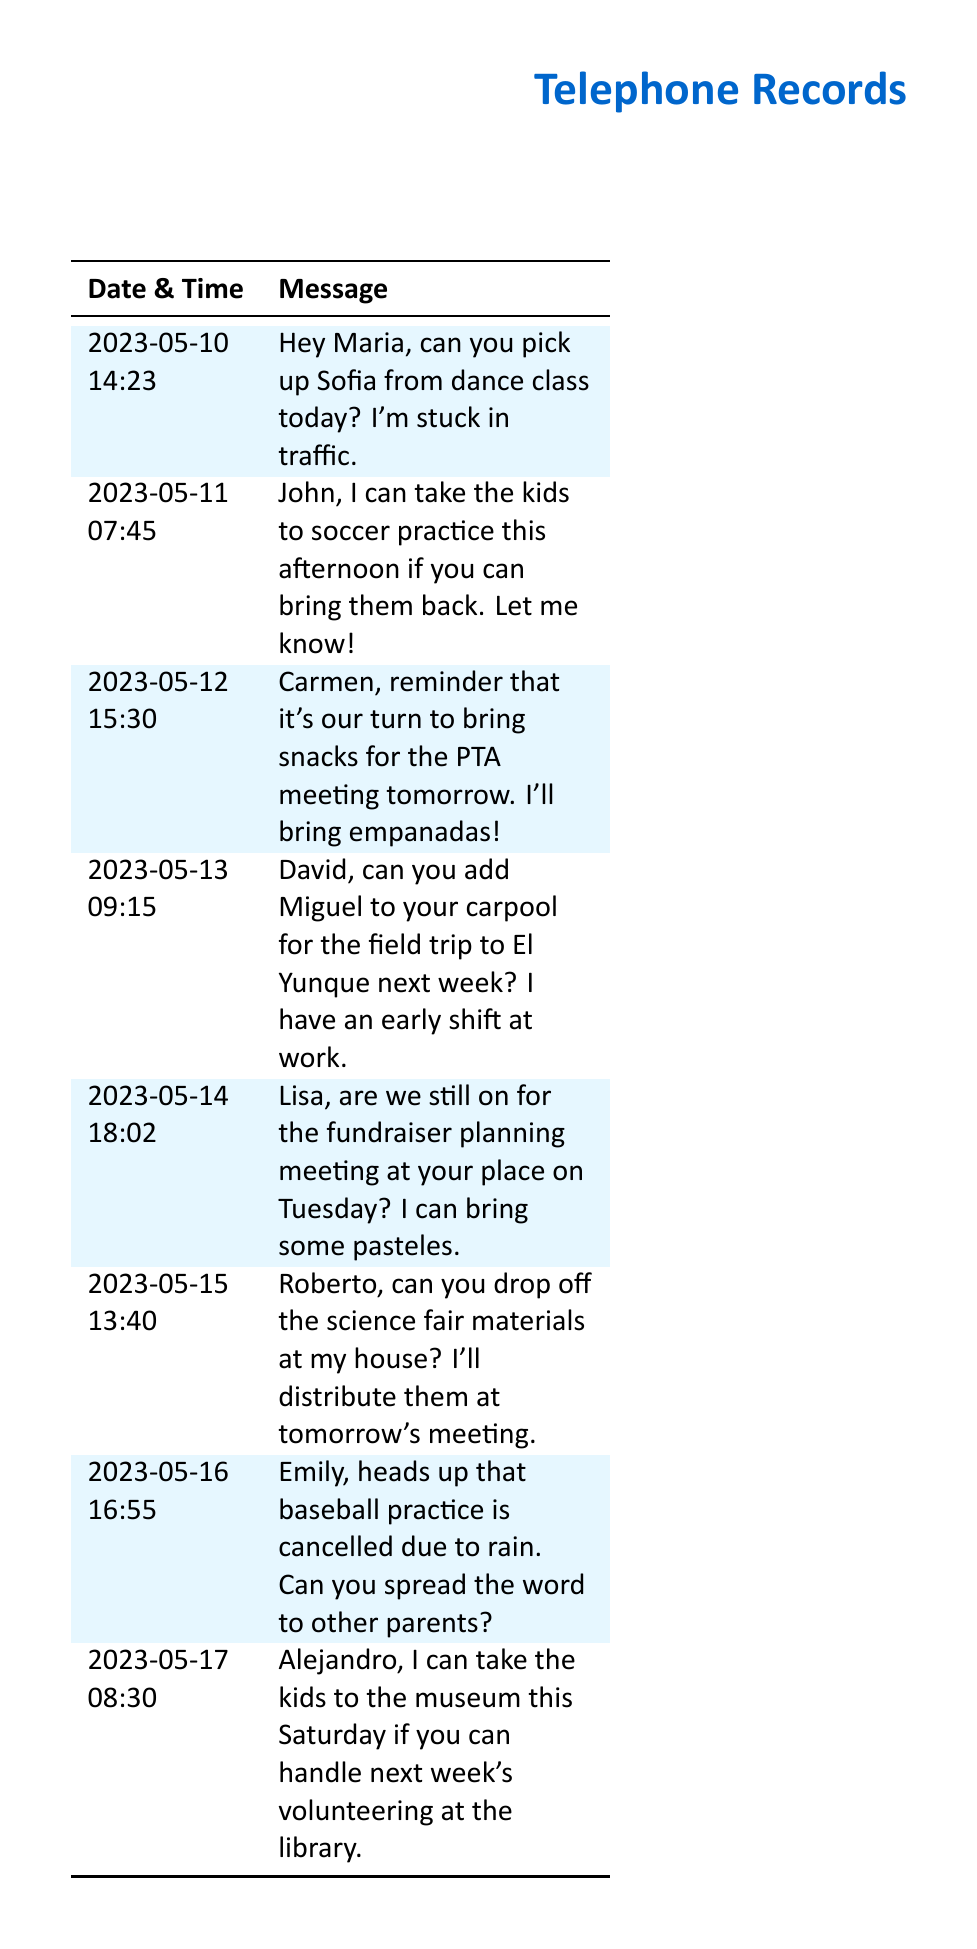What date was the reminder for the PTA meeting sent? The reminder for the PTA meeting was sent on May 12, 2023, as indicated in the text message.
Answer: 2023-05-12 Who is asked to drop off the science fair materials? Roberto is asked to drop off the science fair materials at the sender's house.
Answer: Roberto What time was the message about taking kids to soccer practice sent? The message regarding taking kids to soccer practice was sent at 07:45 on May 11, 2023.
Answer: 07:45 How many messages mention carpooling? There are two messages that mention carpooling: one regarding a field trip and one related to taking kids to the museum.
Answer: 2 What snacks are offered for the PTA meeting? The sender mentioned bringing empanadas for the PTA meeting.
Answer: empanadas Who can take the kids to the museum on Saturday? Alejandro is mentioned as someone who can take the kids to the museum this Saturday.
Answer: Alejandro Which activity was cancelled due to rain? Baseball practice is the activity that was cancelled due to rain.
Answer: baseball practice What is the total number of messages in the document? There are eight messages listed in the telephone records.
Answer: 8 What is the date of the fundraiser planning meeting? The date for the fundraiser planning meeting mentioned is Tuesday, May 14, 2023.
Answer: Tuesday Who is reminded about bringing snacks to the PTA meeting? Carmen is the one reminded about bringing snacks for the PTA meeting.
Answer: Carmen 